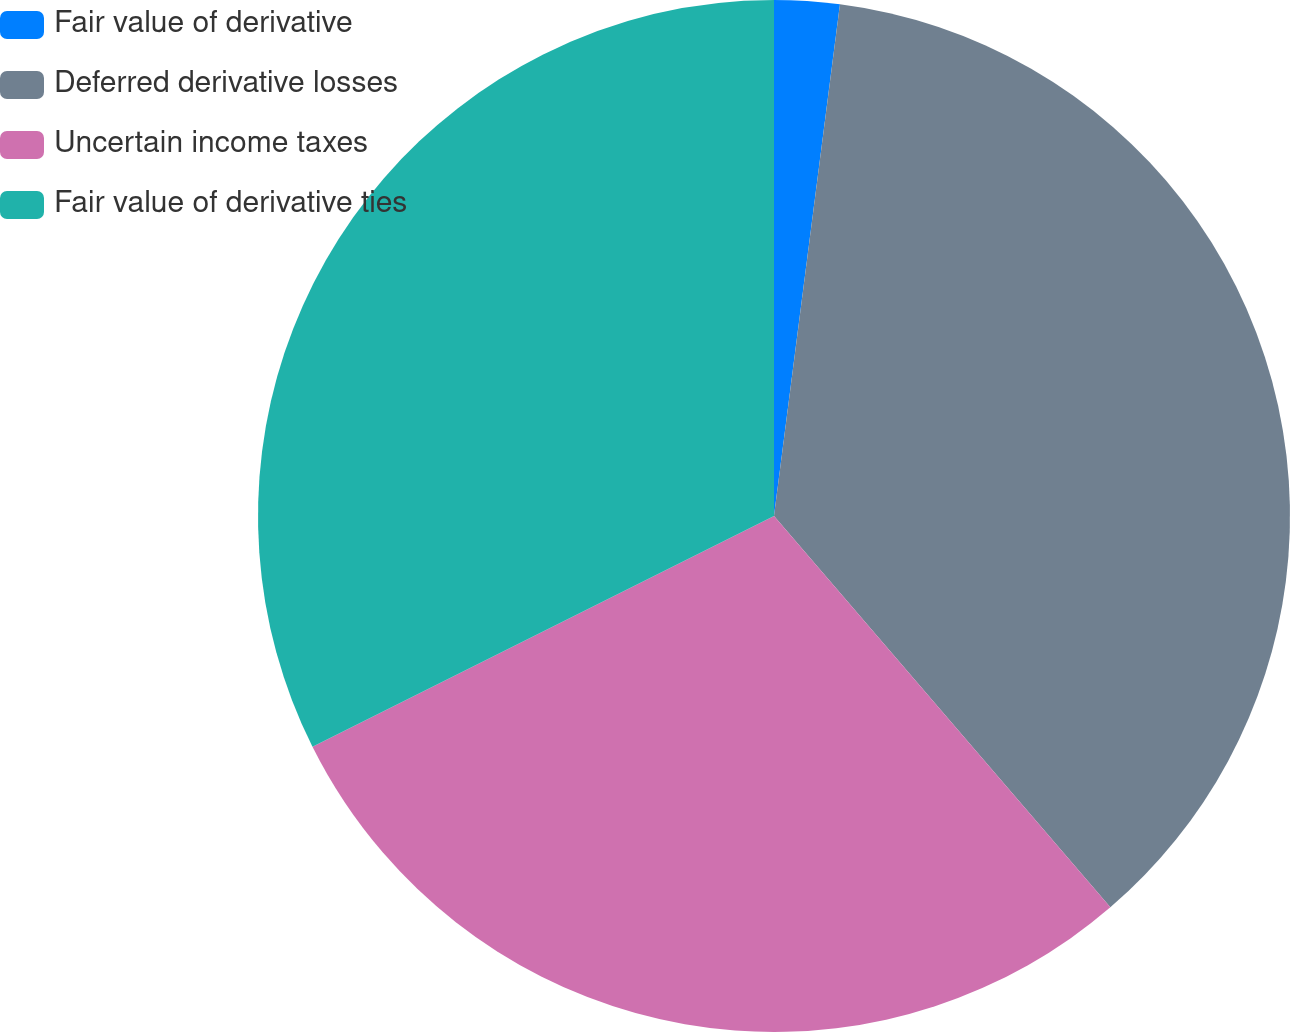Convert chart to OTSL. <chart><loc_0><loc_0><loc_500><loc_500><pie_chart><fcel>Fair value of derivative<fcel>Deferred derivative losses<fcel>Uncertain income taxes<fcel>Fair value of derivative ties<nl><fcel>2.04%<fcel>36.66%<fcel>28.92%<fcel>32.38%<nl></chart> 